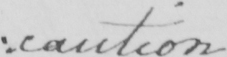What is written in this line of handwriting? caution 